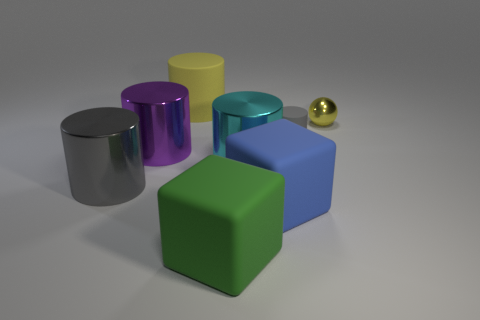Subtract all cyan cylinders. How many cylinders are left? 4 Subtract all purple cylinders. How many cylinders are left? 4 Subtract 1 cylinders. How many cylinders are left? 4 Subtract all green cylinders. Subtract all gray cubes. How many cylinders are left? 5 Add 1 small gray matte objects. How many objects exist? 9 Subtract all spheres. How many objects are left? 7 Subtract all gray cylinders. Subtract all metallic balls. How many objects are left? 5 Add 1 metallic spheres. How many metallic spheres are left? 2 Add 5 rubber objects. How many rubber objects exist? 9 Subtract 0 purple cubes. How many objects are left? 8 